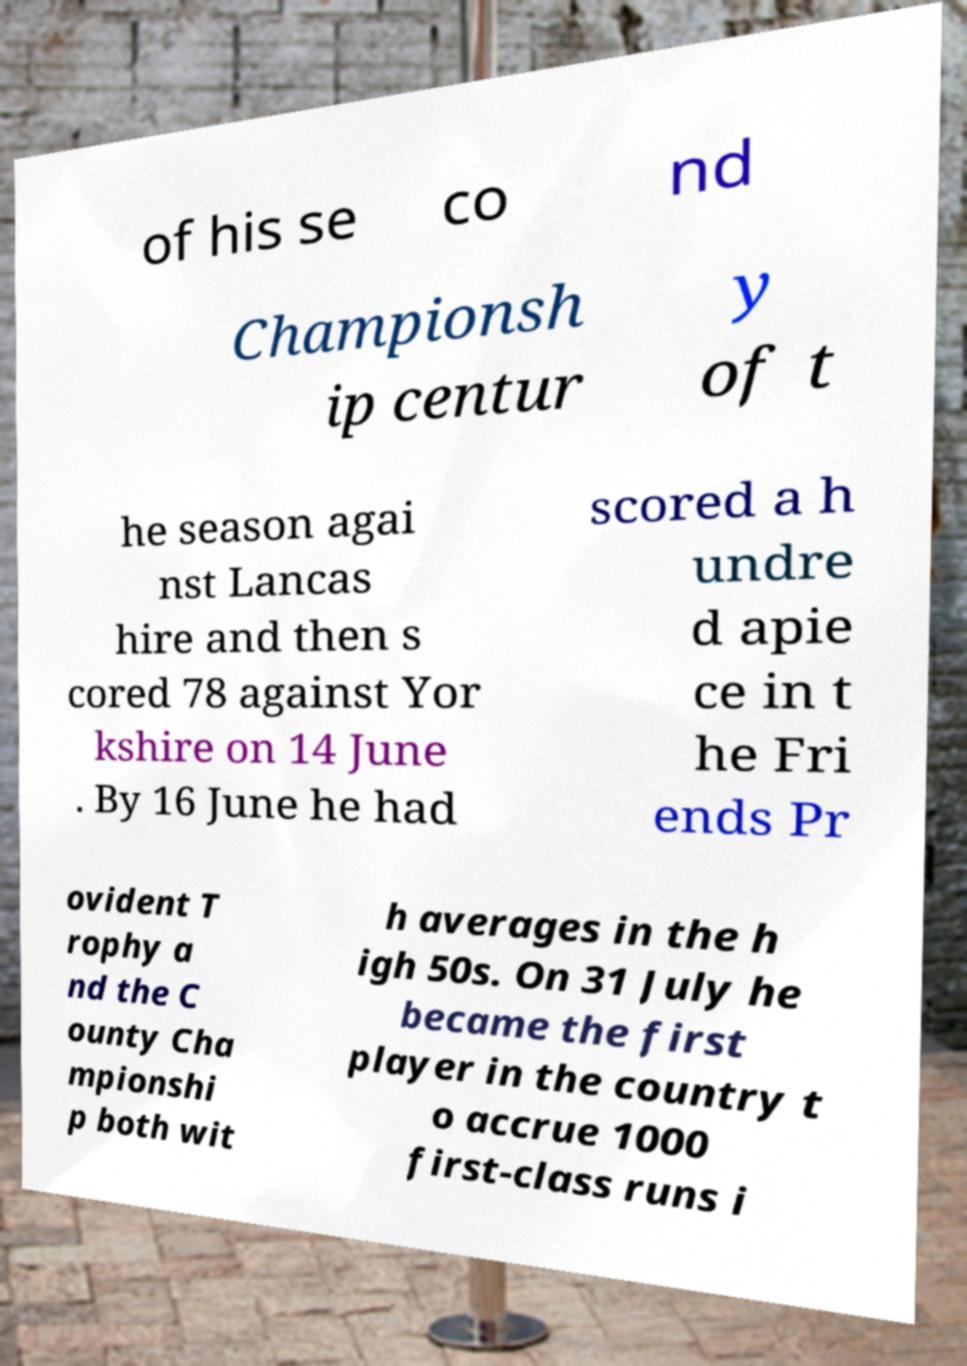There's text embedded in this image that I need extracted. Can you transcribe it verbatim? of his se co nd Championsh ip centur y of t he season agai nst Lancas hire and then s cored 78 against Yor kshire on 14 June . By 16 June he had scored a h undre d apie ce in t he Fri ends Pr ovident T rophy a nd the C ounty Cha mpionshi p both wit h averages in the h igh 50s. On 31 July he became the first player in the country t o accrue 1000 first-class runs i 